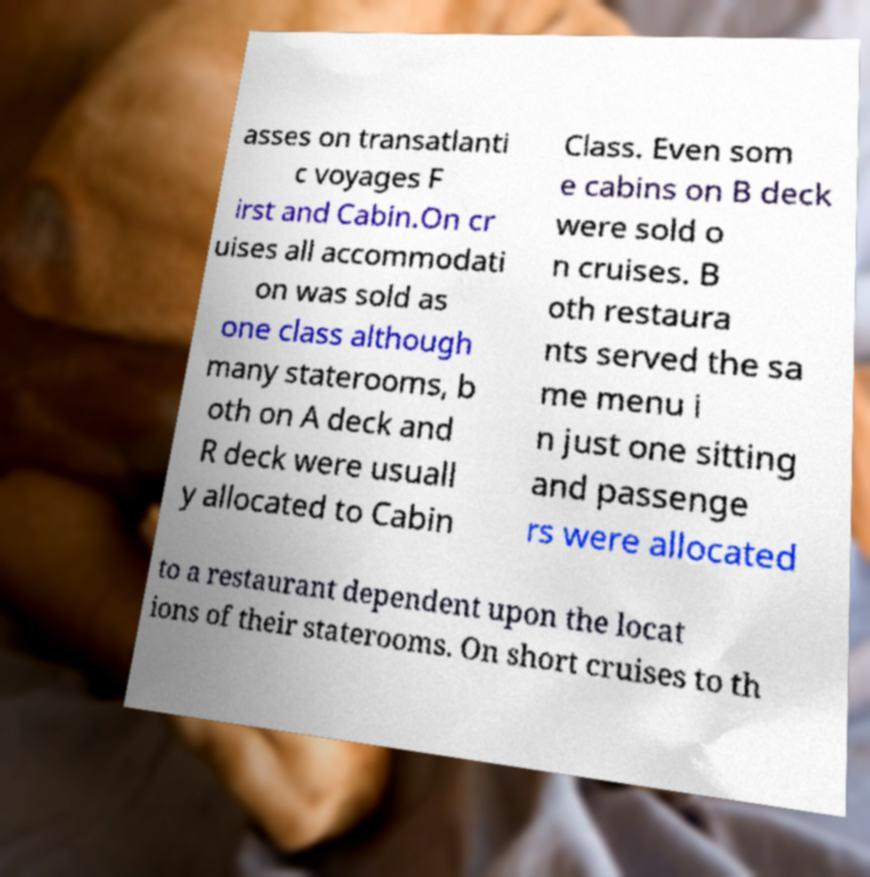I need the written content from this picture converted into text. Can you do that? asses on transatlanti c voyages F irst and Cabin.On cr uises all accommodati on was sold as one class although many staterooms, b oth on A deck and R deck were usuall y allocated to Cabin Class. Even som e cabins on B deck were sold o n cruises. B oth restaura nts served the sa me menu i n just one sitting and passenge rs were allocated to a restaurant dependent upon the locat ions of their staterooms. On short cruises to th 